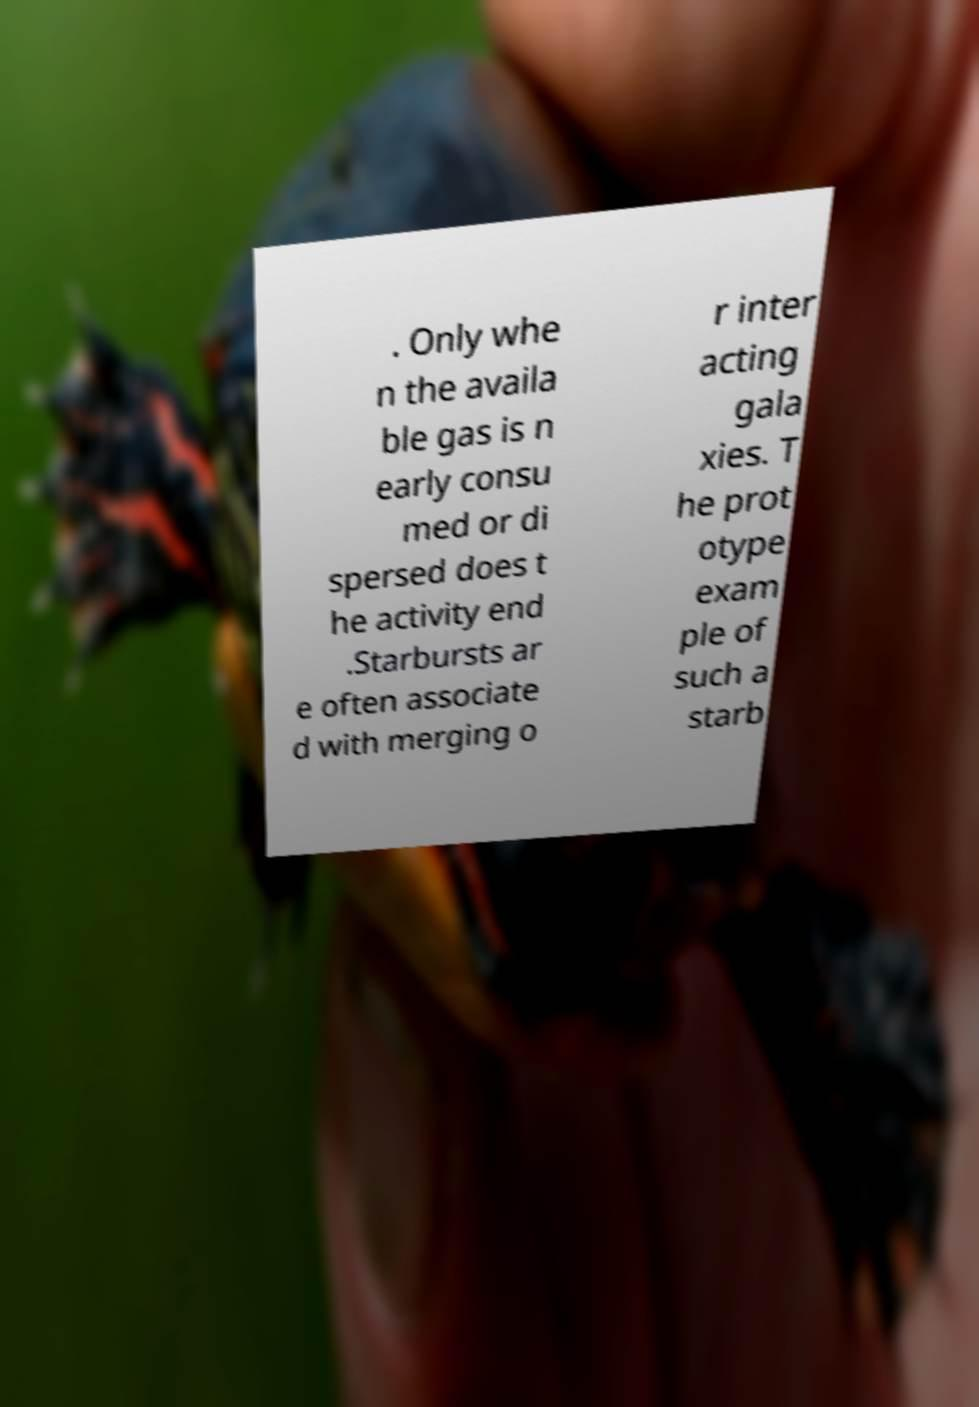Could you assist in decoding the text presented in this image and type it out clearly? . Only whe n the availa ble gas is n early consu med or di spersed does t he activity end .Starbursts ar e often associate d with merging o r inter acting gala xies. T he prot otype exam ple of such a starb 